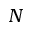<formula> <loc_0><loc_0><loc_500><loc_500>N</formula> 